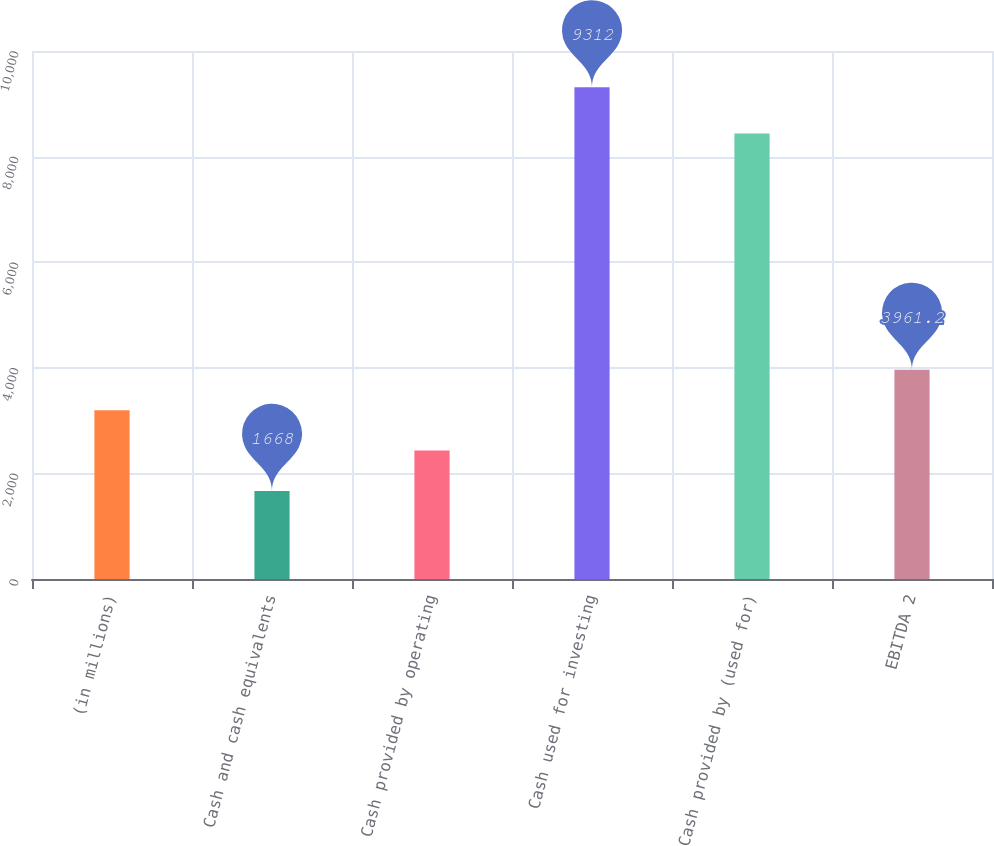<chart> <loc_0><loc_0><loc_500><loc_500><bar_chart><fcel>(in millions)<fcel>Cash and cash equivalents<fcel>Cash provided by operating<fcel>Cash used for investing<fcel>Cash provided by (used for)<fcel>EBITDA 2<nl><fcel>3196.8<fcel>1668<fcel>2432.4<fcel>9312<fcel>8439<fcel>3961.2<nl></chart> 